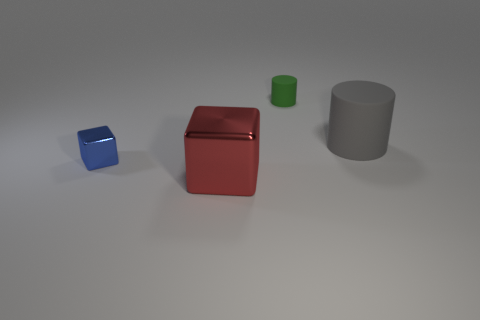Is there a cylinder made of the same material as the green thing?
Ensure brevity in your answer.  Yes. The matte object to the right of the small green object is what color?
Your response must be concise. Gray. Is the shape of the tiny shiny thing the same as the big object that is on the left side of the green matte thing?
Offer a terse response. Yes. The other cylinder that is made of the same material as the tiny green cylinder is what size?
Offer a terse response. Large. There is a matte object that is to the right of the small green rubber cylinder; does it have the same shape as the tiny matte thing?
Make the answer very short. Yes. What number of blue blocks have the same size as the green matte thing?
Make the answer very short. 1. There is a cylinder that is left of the gray object; are there any large cylinders behind it?
Keep it short and to the point. No. How many objects are either tiny things that are to the left of the big red object or big shiny blocks?
Make the answer very short. 2. How many yellow metal cylinders are there?
Offer a very short reply. 0. What is the shape of the other big thing that is the same material as the green thing?
Provide a succinct answer. Cylinder. 